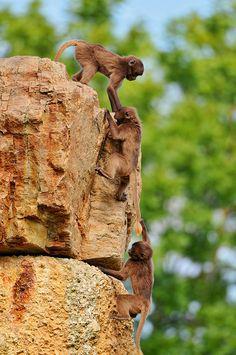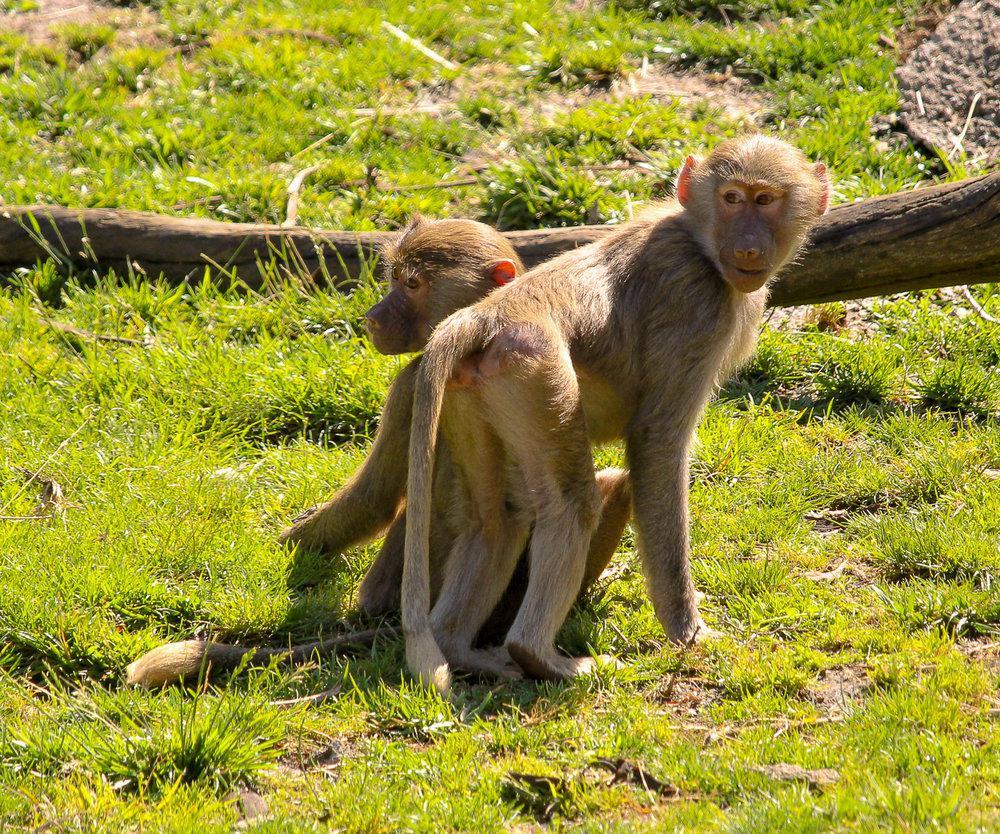The first image is the image on the left, the second image is the image on the right. Analyze the images presented: Is the assertion "An image includes a brown monkey with its arms reaching down below its head and its rear higher than its head." valid? Answer yes or no. Yes. 